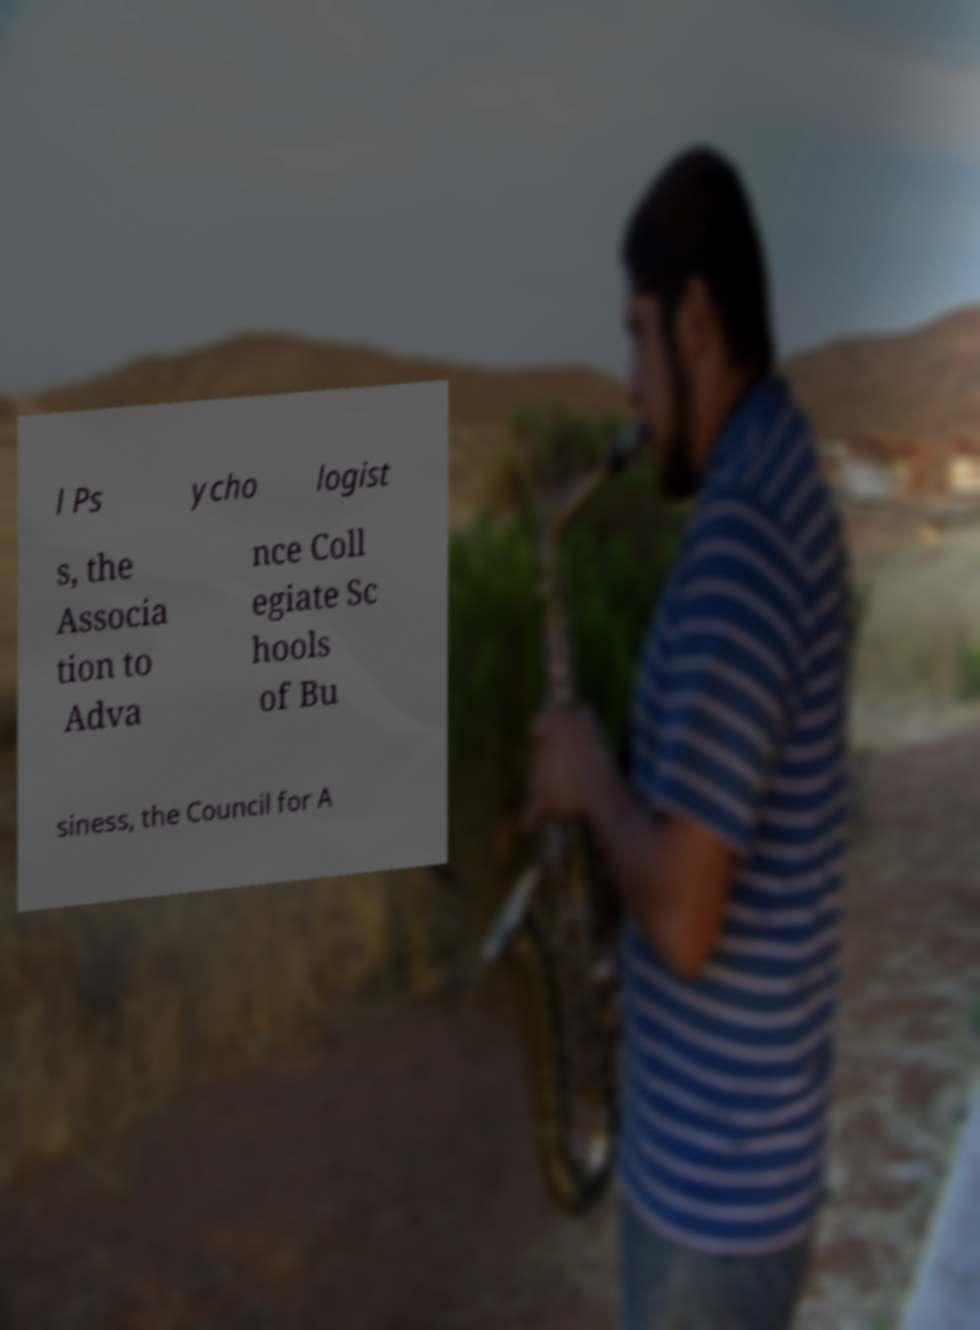Please identify and transcribe the text found in this image. l Ps ycho logist s, the Associa tion to Adva nce Coll egiate Sc hools of Bu siness, the Council for A 